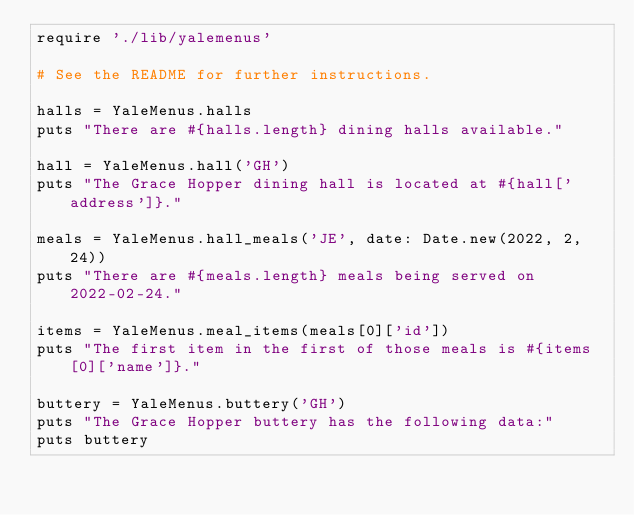Convert code to text. <code><loc_0><loc_0><loc_500><loc_500><_Ruby_>require './lib/yalemenus'

# See the README for further instructions.

halls = YaleMenus.halls
puts "There are #{halls.length} dining halls available."

hall = YaleMenus.hall('GH')
puts "The Grace Hopper dining hall is located at #{hall['address']}."

meals = YaleMenus.hall_meals('JE', date: Date.new(2022, 2, 24))
puts "There are #{meals.length} meals being served on 2022-02-24."

items = YaleMenus.meal_items(meals[0]['id'])
puts "The first item in the first of those meals is #{items[0]['name']}."

buttery = YaleMenus.buttery('GH')
puts "The Grace Hopper buttery has the following data:"
puts buttery
</code> 